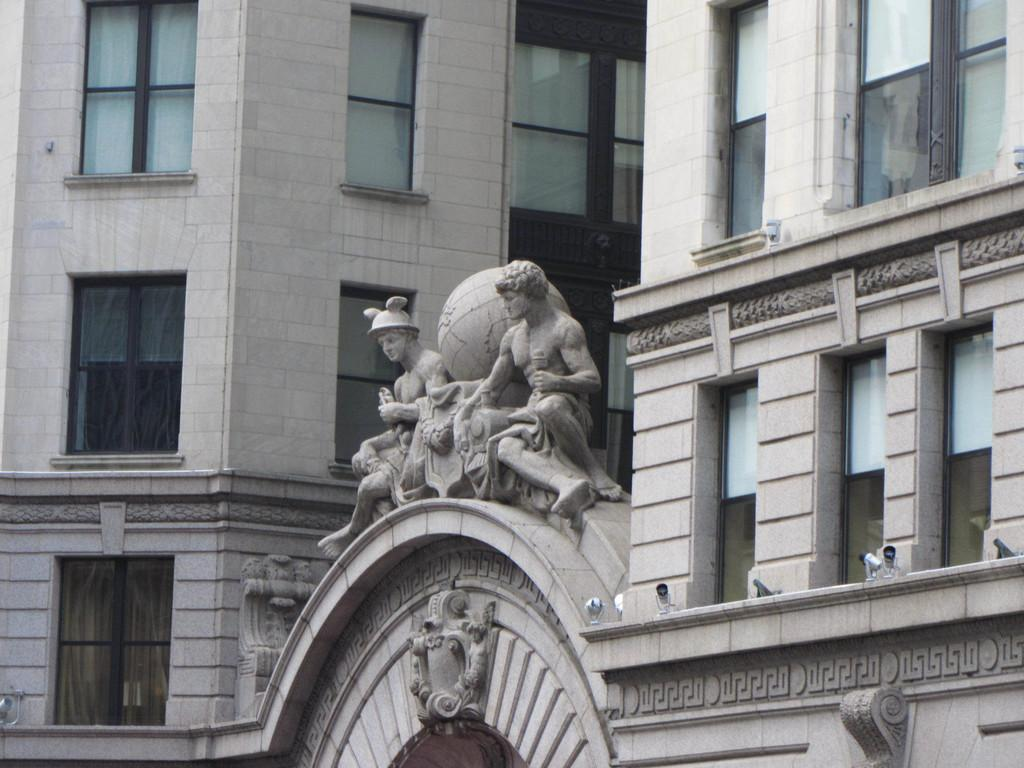What can be seen on the wall in the image? There are sculptures and designs on the wall. What can be seen illuminating the area in the image? There are lights visible in the image. What is visible in the background of the image? There are buildings, walls, and glass windows in the background. What flavor of yarn is being used to create the designs on the wall? There is no yarn present in the image, and the designs on the wall are not created using yarn. Can you hear any noise in the image? The image is silent, and there is no indication of any noise or sound. 